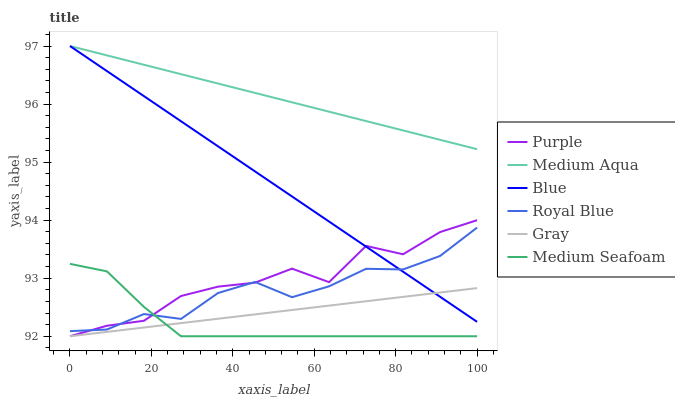Does Medium Seafoam have the minimum area under the curve?
Answer yes or no. Yes. Does Medium Aqua have the maximum area under the curve?
Answer yes or no. Yes. Does Gray have the minimum area under the curve?
Answer yes or no. No. Does Gray have the maximum area under the curve?
Answer yes or no. No. Is Gray the smoothest?
Answer yes or no. Yes. Is Purple the roughest?
Answer yes or no. Yes. Is Purple the smoothest?
Answer yes or no. No. Is Gray the roughest?
Answer yes or no. No. Does Gray have the lowest value?
Answer yes or no. Yes. Does Royal Blue have the lowest value?
Answer yes or no. No. Does Medium Aqua have the highest value?
Answer yes or no. Yes. Does Purple have the highest value?
Answer yes or no. No. Is Gray less than Royal Blue?
Answer yes or no. Yes. Is Medium Aqua greater than Purple?
Answer yes or no. Yes. Does Medium Seafoam intersect Purple?
Answer yes or no. Yes. Is Medium Seafoam less than Purple?
Answer yes or no. No. Is Medium Seafoam greater than Purple?
Answer yes or no. No. Does Gray intersect Royal Blue?
Answer yes or no. No. 